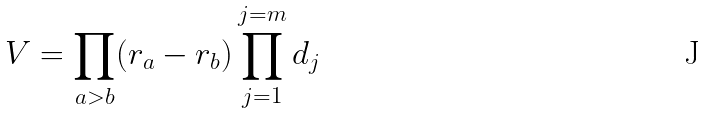Convert formula to latex. <formula><loc_0><loc_0><loc_500><loc_500>V = \prod _ { a > b } ( r _ { a } - r _ { b } ) \prod _ { j = 1 } ^ { j = m } d _ { j }</formula> 